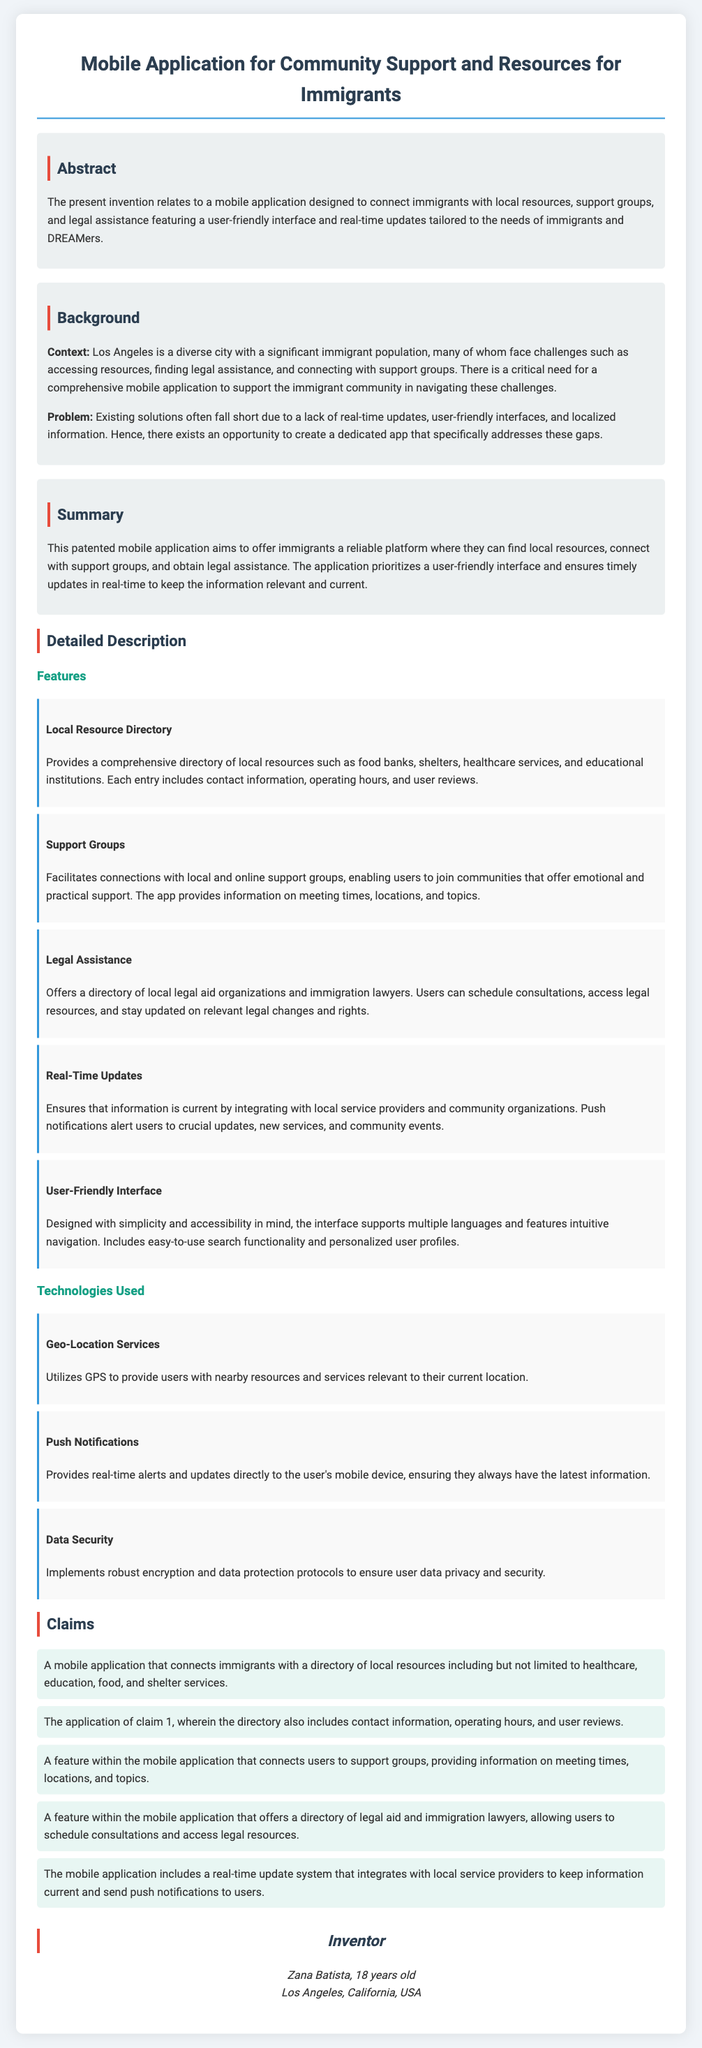What is the title of the patent application? The title of the patent application is stated at the beginning of the document.
Answer: Mobile Application for Community Support and Resources for Immigrants Who is the inventor of the application? The inventor is mentioned in the section at the end of the document.
Answer: Zana Batista What city is highlighted for its significant immigrant population? The document specifies the city known for its diversity and immigrant community.
Answer: Los Angeles What feature connects users with legal assistance? This feature is mentioned in the descriptions of the application’s functionalities.
Answer: Legal Assistance What is one technology used in the application? The technologies are listed with their descriptions within the document.
Answer: Geo-Location Services How many claims are listed in the application? The total number of claims is stated at the beginning of the claims section.
Answer: Five What kind of updates does the application provide? The updates available through the application are described in detail.
Answer: Real-Time Updates What user interface consideration is mentioned? The document discusses specific design elements aimed at user experience.
Answer: User-Friendly Interface What type of resources does the app directory provide? The types of resources available in the app are detailed in one of the features.
Answer: Local resources 